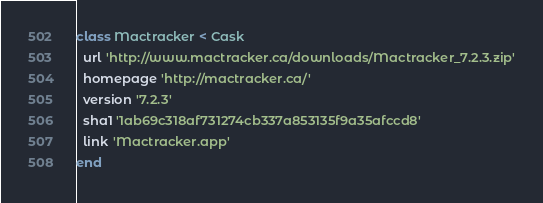Convert code to text. <code><loc_0><loc_0><loc_500><loc_500><_Ruby_>class Mactracker < Cask
  url 'http://www.mactracker.ca/downloads/Mactracker_7.2.3.zip'
  homepage 'http://mactracker.ca/'
  version '7.2.3'
  sha1 '1ab69c318af731274cb337a853135f9a35afccd8'
  link 'Mactracker.app'
end
</code> 